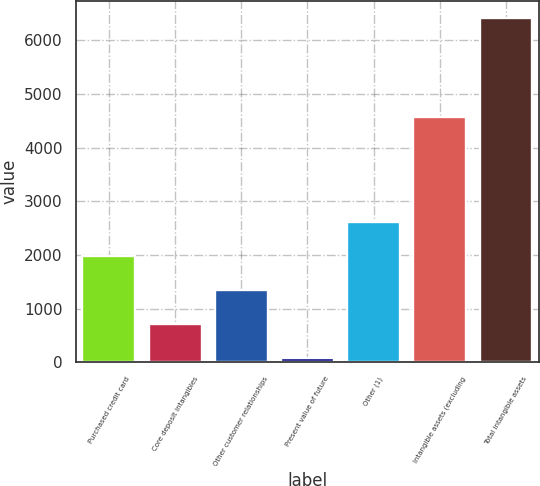<chart> <loc_0><loc_0><loc_500><loc_500><bar_chart><fcel>Purchased credit card<fcel>Core deposit intangibles<fcel>Other customer relationships<fcel>Present value of future<fcel>Other (1)<fcel>Intangible assets (excluding<fcel>Total intangible assets<nl><fcel>1978.6<fcel>712.2<fcel>1345.4<fcel>79<fcel>2611.8<fcel>4566<fcel>6411<nl></chart> 